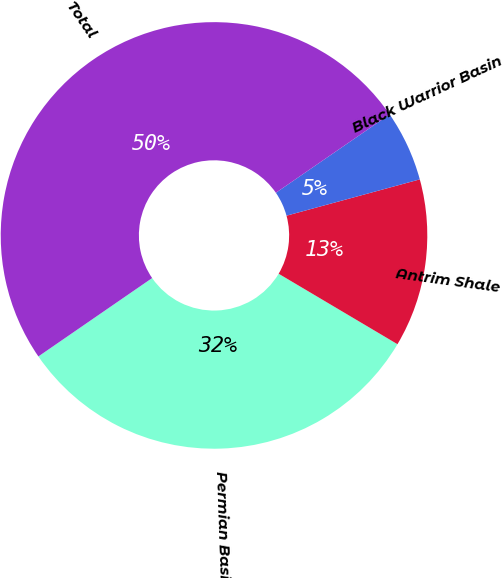Convert chart to OTSL. <chart><loc_0><loc_0><loc_500><loc_500><pie_chart><fcel>Permian Basin<fcel>Antrim Shale<fcel>Black Warrior Basin<fcel>Total<nl><fcel>31.88%<fcel>12.75%<fcel>5.37%<fcel>50.0%<nl></chart> 